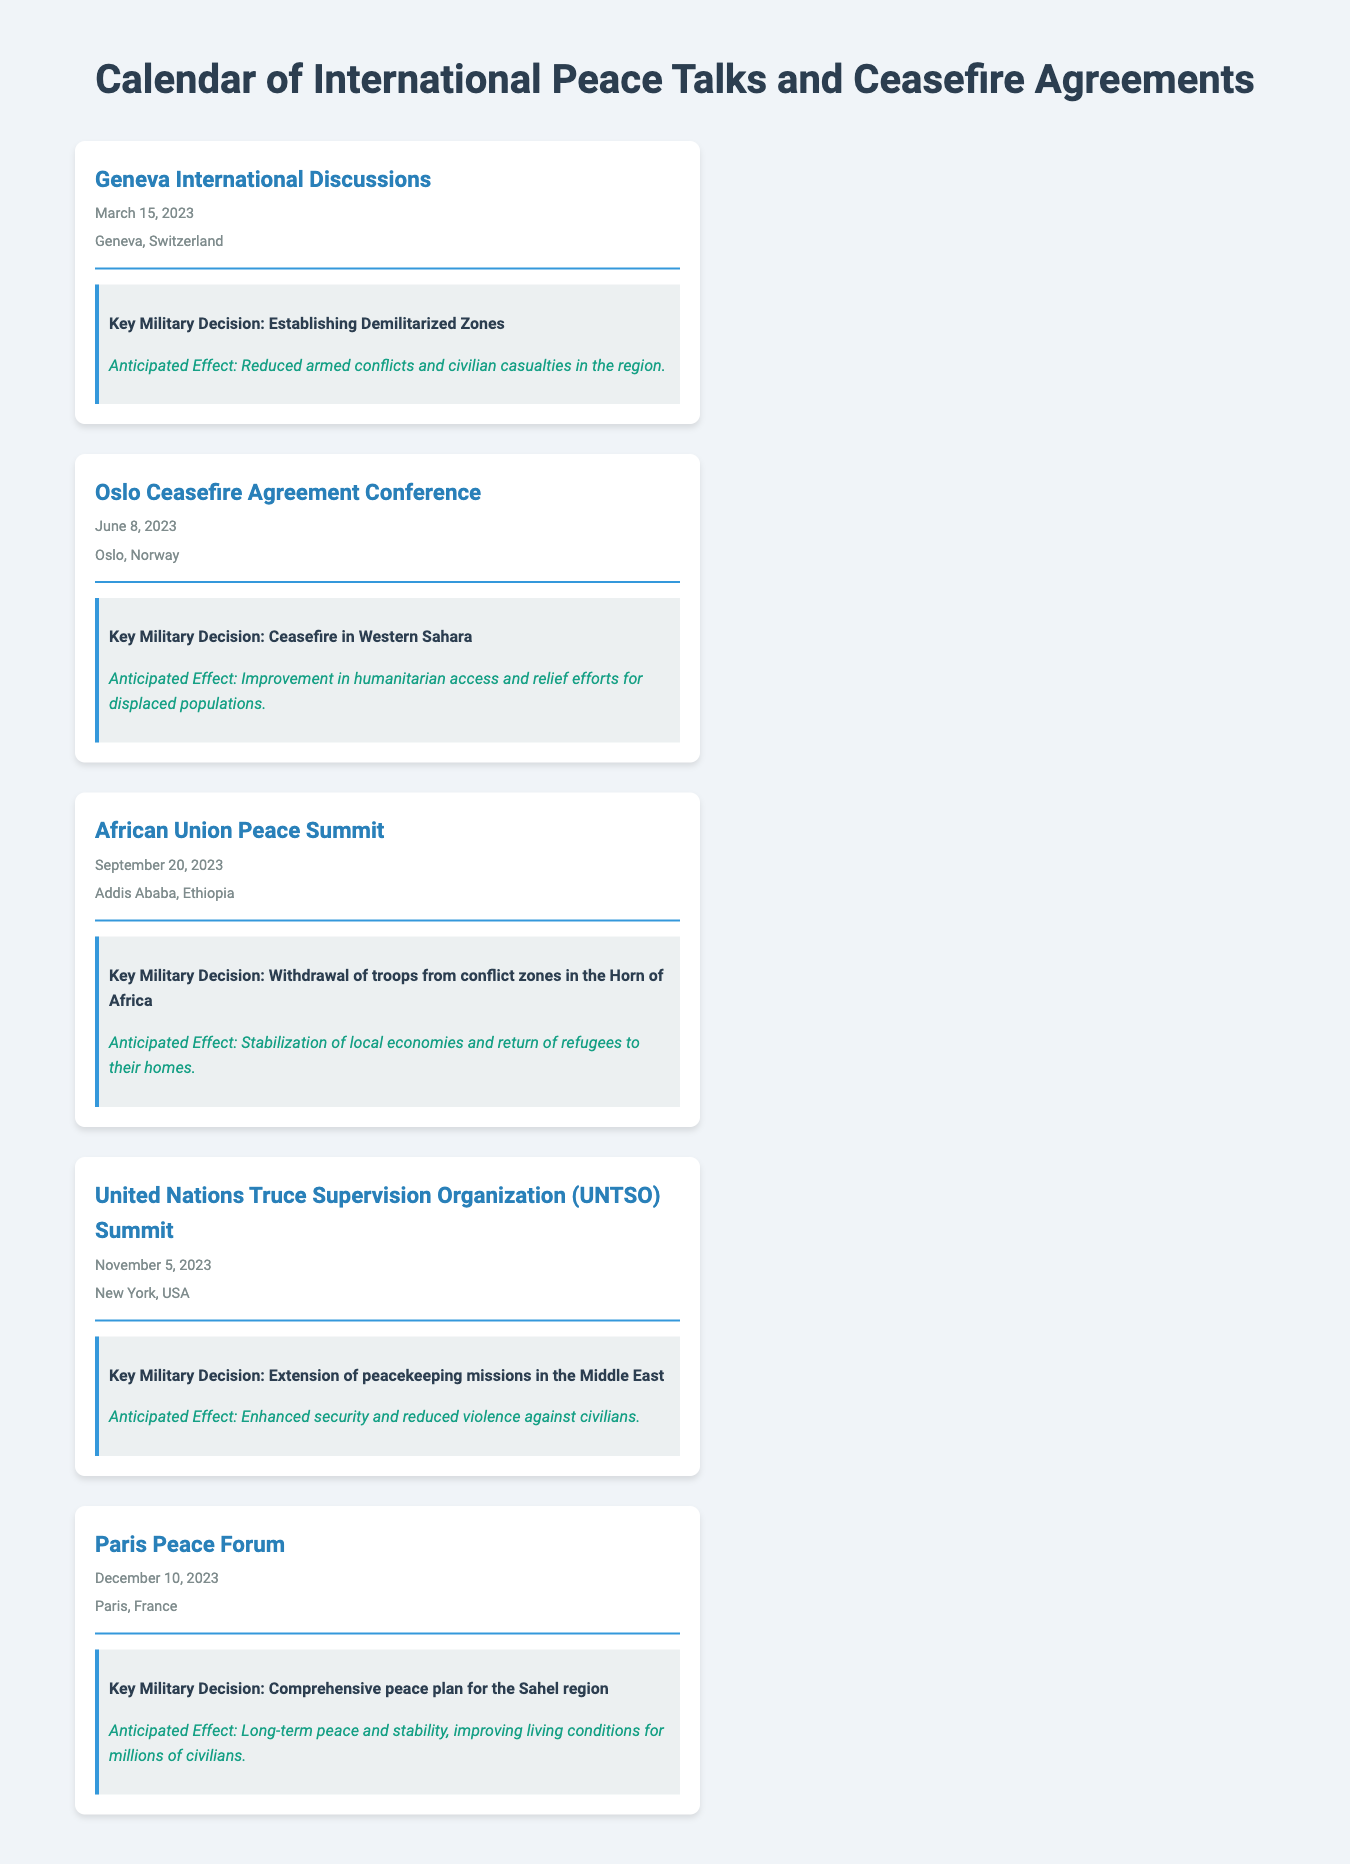what is the date of the Geneva International Discussions? The date is specified in the document under the event name, which is March 15, 2023.
Answer: March 15, 2023 where is the Oslo Ceasefire Agreement Conference held? The location is listed in the document along with the event details, which is Oslo, Norway.
Answer: Oslo, Norway what is the key military decision made at the African Union Peace Summit? The decision is found in the description of the event, which is the withdrawal of troops from conflict zones in the Horn of Africa.
Answer: Withdrawal of troops from conflict zones in the Horn of Africa what is the anticipated effect of the ceasefire in Western Sahara? The effect is mentioned in the event details, indicating improvement in humanitarian access and relief efforts for displaced populations.
Answer: Improvement in humanitarian access and relief efforts for displaced populations how many peace talks are listed in the document? The document details five events related to peace talks and ceasefire agreements.
Answer: Five what is the name of the summit taking place on November 5, 2023? The name of the summit is explicitly mentioned in the document, which is the United Nations Truce Supervision Organization (UNTSO) Summit.
Answer: United Nations Truce Supervision Organization (UNTSO) Summit what is the anticipated effect of the comprehensive peace plan for the Sahel region? The anticipated effect is described in the document, stating it will lead to long-term peace and stability, improving living conditions for millions of civilians.
Answer: Long-term peace and stability, improving living conditions for millions of civilians which country is the venue for the Paris Peace Forum? The venue location is stated in the event description, which is Paris, France.
Answer: Paris, France what is the military decision made during the UNTSO Summit? The military decision is specified in the document as the extension of peacekeeping missions in the Middle East.
Answer: Extension of peacekeeping missions in the Middle East 